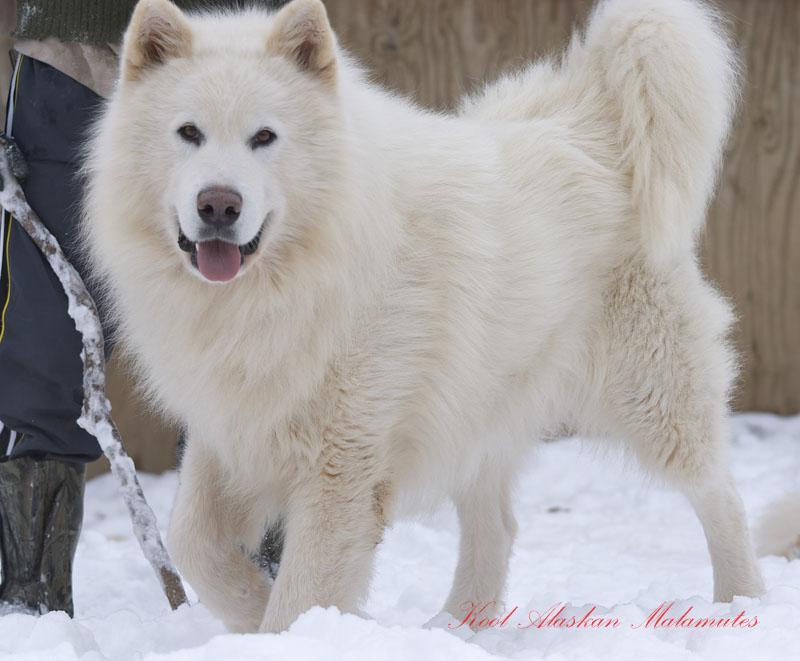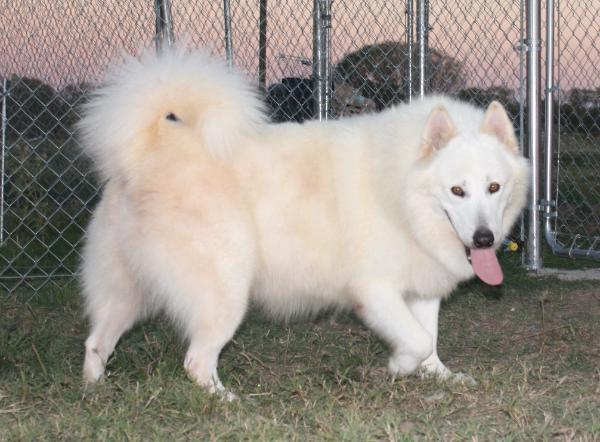The first image is the image on the left, the second image is the image on the right. Examine the images to the left and right. Is the description "The image on the right shows a left-facing dog standing in front of its owner." accurate? Answer yes or no. No. The first image is the image on the left, the second image is the image on the right. Given the left and right images, does the statement "All dogs are huskies with dark-and-white fur who are standing in profile, and the dogs on the left and right do not face the same [left or right] direction." hold true? Answer yes or no. No. 